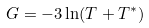Convert formula to latex. <formula><loc_0><loc_0><loc_500><loc_500>G = - 3 \ln ( T + T ^ { * } )</formula> 